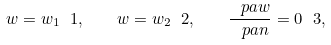Convert formula to latex. <formula><loc_0><loc_0><loc_500><loc_500>w = w _ { 1 } \ 1 , \quad w = w _ { 2 } \ 2 , \quad \frac { \ p a w } { \ p a n } = 0 \ 3 ,</formula> 